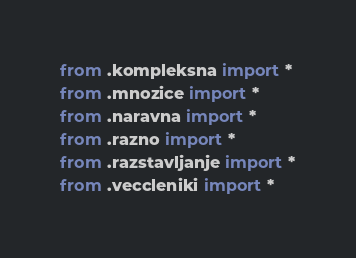Convert code to text. <code><loc_0><loc_0><loc_500><loc_500><_Python_>from .kompleksna import *
from .mnozice import *
from .naravna import *
from .razno import *
from .razstavljanje import *
from .veccleniki import *
</code> 